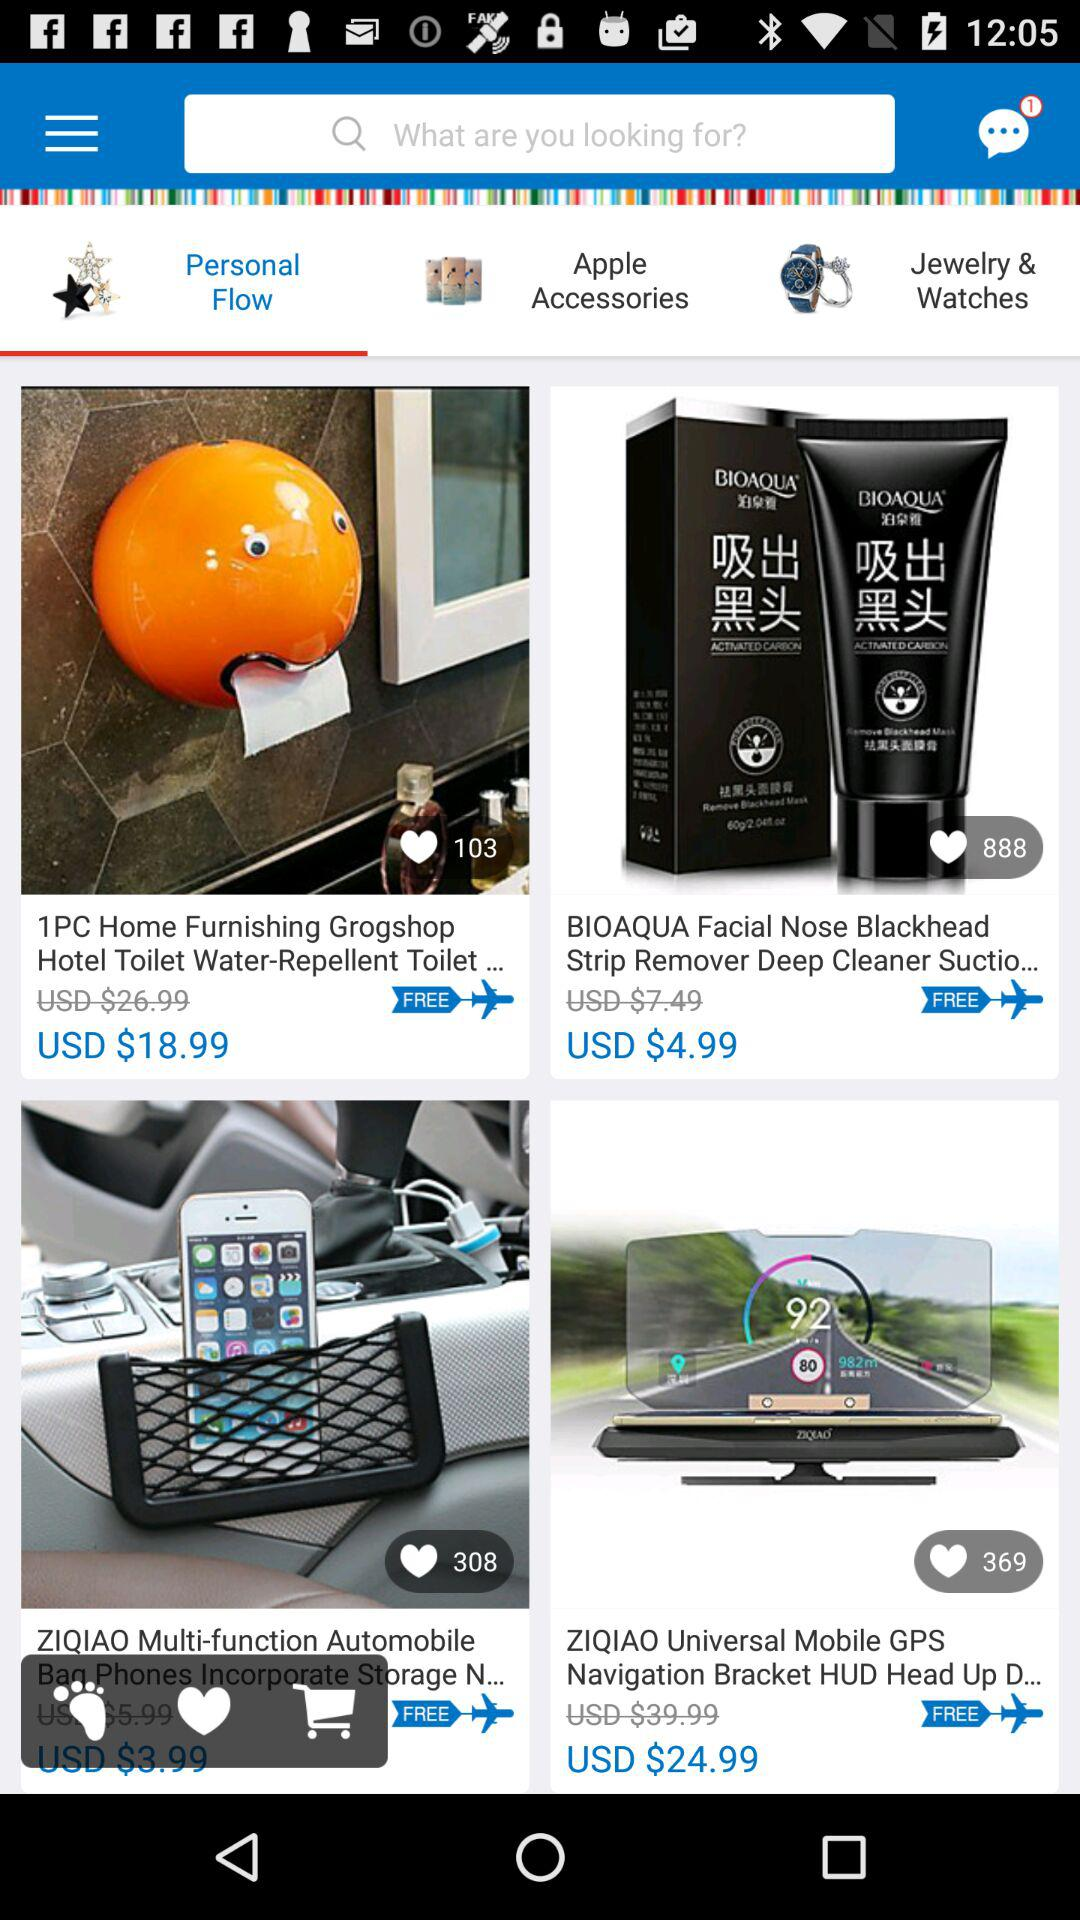What is the cost of 1 piece grogshop? The cost of 1 piece of "Home Furnishing Grogshop Hotel Toilet Water-Repellent Toilet..." is USD $18.99. 